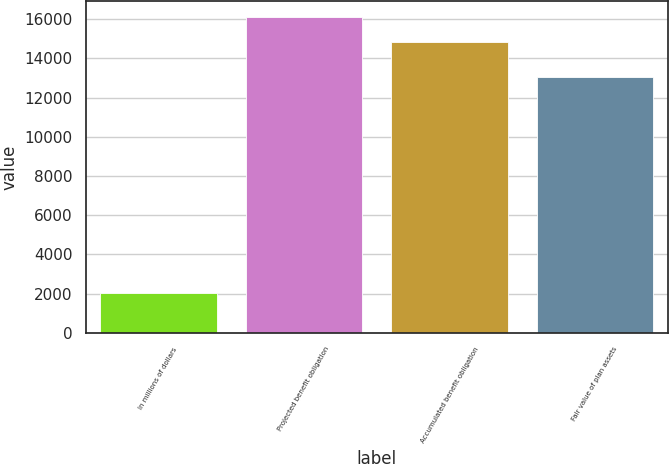<chart> <loc_0><loc_0><loc_500><loc_500><bar_chart><fcel>In millions of dollars<fcel>Projected benefit obligation<fcel>Accumulated benefit obligation<fcel>Fair value of plan assets<nl><fcel>2014<fcel>16103.5<fcel>14821<fcel>13071<nl></chart> 